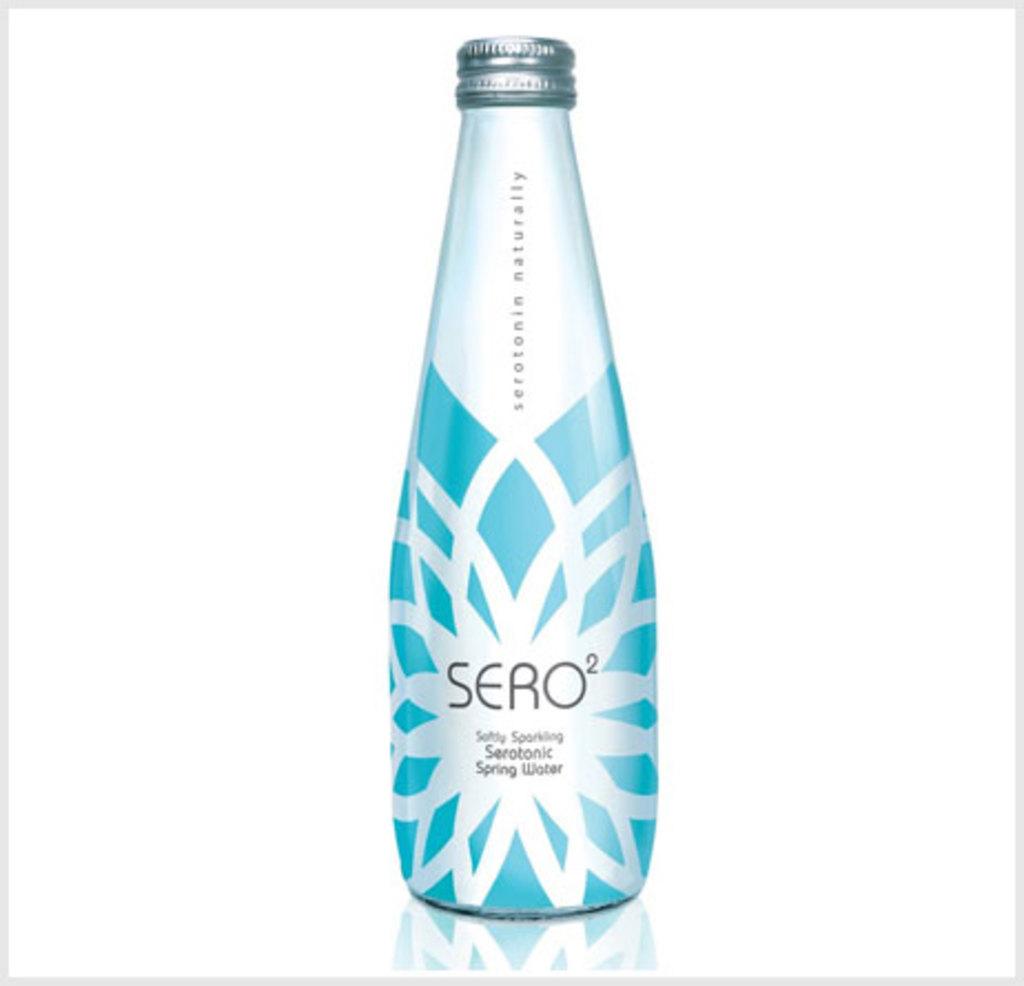Is this sero?
Offer a terse response. Yes. What do the two words written vertically say?
Ensure brevity in your answer.  Serotonin naturally. 